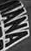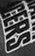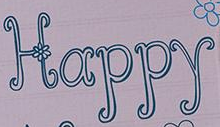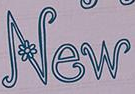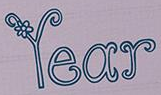What words can you see in these images in sequence, separated by a semicolon? IANA; CERS; Happy; New; Year 